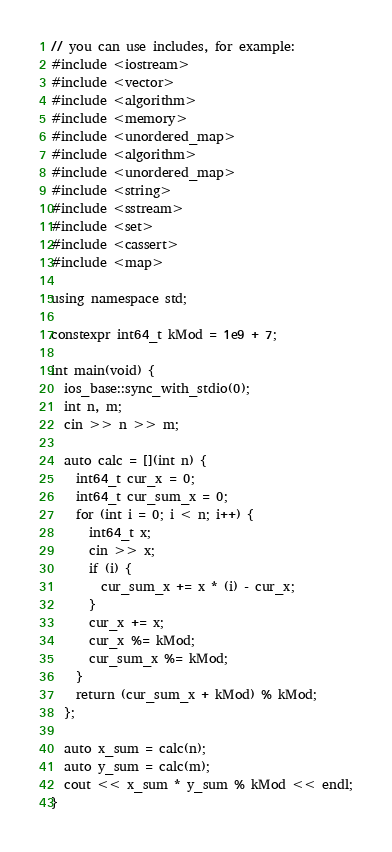<code> <loc_0><loc_0><loc_500><loc_500><_C++_>// you can use includes, for example:
#include <iostream>
#include <vector>
#include <algorithm>
#include <memory>
#include <unordered_map>
#include <algorithm>
#include <unordered_map>
#include <string>
#include <sstream>
#include <set>
#include <cassert>
#include <map>

using namespace std;

constexpr int64_t kMod = 1e9 + 7;

int main(void) {
  ios_base::sync_with_stdio(0);
  int n, m;
  cin >> n >> m;

  auto calc = [](int n) {
    int64_t cur_x = 0;
    int64_t cur_sum_x = 0;
    for (int i = 0; i < n; i++) {
      int64_t x;
      cin >> x;
      if (i) {
        cur_sum_x += x * (i) - cur_x;
      }
      cur_x += x;
      cur_x %= kMod;
      cur_sum_x %= kMod;
    }
    return (cur_sum_x + kMod) % kMod;
  };

  auto x_sum = calc(n);
  auto y_sum = calc(m);
  cout << x_sum * y_sum % kMod << endl;
}
</code> 